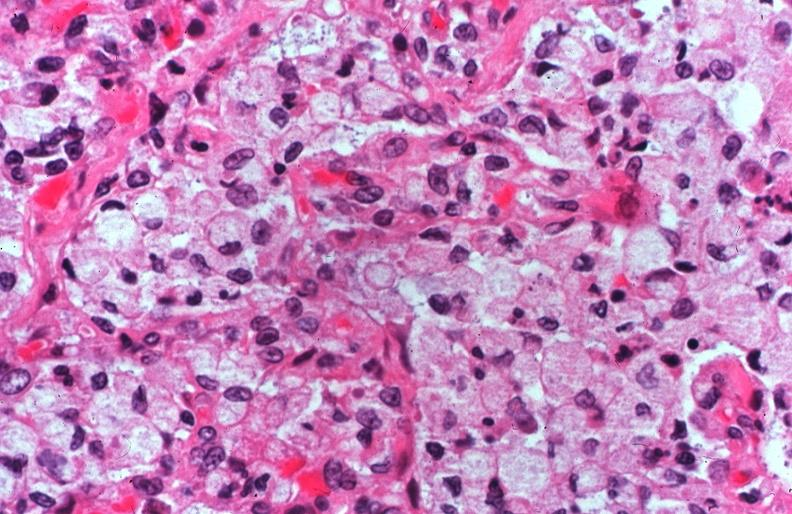what does this image show?
Answer the question using a single word or phrase. Lung 